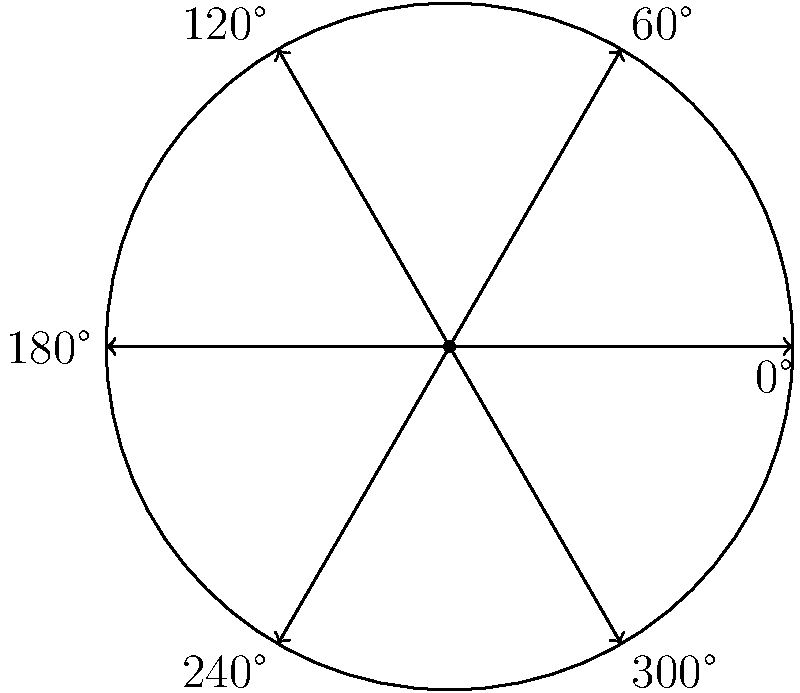As a fashion designer, you're creating a circular brooch with six equally spaced gemstones. If the first gemstone is placed at 0°, and you rotate the design counterclockwise by 150°, at which angle will the new position of the first gemstone be? To solve this problem, we need to follow these steps:

1. Understand the initial setup:
   - The brooch has six equally spaced gemstones.
   - The gemstones are placed at 0°, 60°, 120°, 180°, 240°, and 300°.
   - The first gemstone starts at 0°.

2. Apply the rotation:
   - We need to rotate the entire design counterclockwise by 150°.
   - In mathematics, counterclockwise rotation is positive.

3. Calculate the new position:
   - New position = Initial position + Rotation angle
   - New position = 0° + 150° = 150°

4. Normalize the angle:
   - Since we're working with a circle, we need to ensure our answer is between 0° and 360°.
   - 150° is already within this range, so no further adjustment is needed.

Therefore, after rotating the design counterclockwise by 150°, the first gemstone will be at 150°.
Answer: 150° 